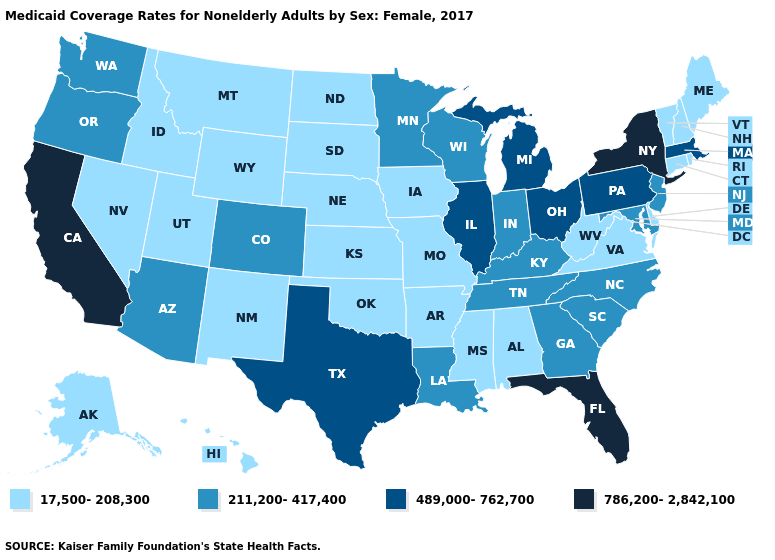Which states have the lowest value in the USA?
Answer briefly. Alabama, Alaska, Arkansas, Connecticut, Delaware, Hawaii, Idaho, Iowa, Kansas, Maine, Mississippi, Missouri, Montana, Nebraska, Nevada, New Hampshire, New Mexico, North Dakota, Oklahoma, Rhode Island, South Dakota, Utah, Vermont, Virginia, West Virginia, Wyoming. Name the states that have a value in the range 17,500-208,300?
Be succinct. Alabama, Alaska, Arkansas, Connecticut, Delaware, Hawaii, Idaho, Iowa, Kansas, Maine, Mississippi, Missouri, Montana, Nebraska, Nevada, New Hampshire, New Mexico, North Dakota, Oklahoma, Rhode Island, South Dakota, Utah, Vermont, Virginia, West Virginia, Wyoming. What is the lowest value in states that border Kentucky?
Give a very brief answer. 17,500-208,300. What is the value of Maine?
Concise answer only. 17,500-208,300. Among the states that border New Mexico , which have the lowest value?
Short answer required. Oklahoma, Utah. What is the highest value in the USA?
Write a very short answer. 786,200-2,842,100. Name the states that have a value in the range 17,500-208,300?
Answer briefly. Alabama, Alaska, Arkansas, Connecticut, Delaware, Hawaii, Idaho, Iowa, Kansas, Maine, Mississippi, Missouri, Montana, Nebraska, Nevada, New Hampshire, New Mexico, North Dakota, Oklahoma, Rhode Island, South Dakota, Utah, Vermont, Virginia, West Virginia, Wyoming. What is the value of Hawaii?
Quick response, please. 17,500-208,300. What is the highest value in the West ?
Write a very short answer. 786,200-2,842,100. Name the states that have a value in the range 489,000-762,700?
Answer briefly. Illinois, Massachusetts, Michigan, Ohio, Pennsylvania, Texas. Does South Carolina have the lowest value in the USA?
Quick response, please. No. What is the highest value in the West ?
Write a very short answer. 786,200-2,842,100. Does California have the highest value in the USA?
Concise answer only. Yes. Name the states that have a value in the range 211,200-417,400?
Write a very short answer. Arizona, Colorado, Georgia, Indiana, Kentucky, Louisiana, Maryland, Minnesota, New Jersey, North Carolina, Oregon, South Carolina, Tennessee, Washington, Wisconsin. Name the states that have a value in the range 489,000-762,700?
Short answer required. Illinois, Massachusetts, Michigan, Ohio, Pennsylvania, Texas. 